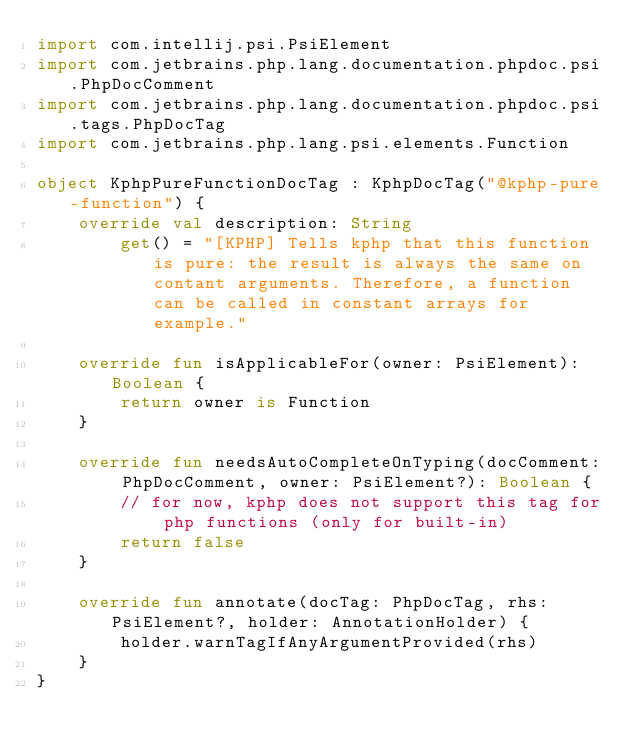<code> <loc_0><loc_0><loc_500><loc_500><_Kotlin_>import com.intellij.psi.PsiElement
import com.jetbrains.php.lang.documentation.phpdoc.psi.PhpDocComment
import com.jetbrains.php.lang.documentation.phpdoc.psi.tags.PhpDocTag
import com.jetbrains.php.lang.psi.elements.Function

object KphpPureFunctionDocTag : KphpDocTag("@kphp-pure-function") {
    override val description: String
        get() = "[KPHP] Tells kphp that this function is pure: the result is always the same on contant arguments. Therefore, a function can be called in constant arrays for example."

    override fun isApplicableFor(owner: PsiElement): Boolean {
        return owner is Function
    }

    override fun needsAutoCompleteOnTyping(docComment: PhpDocComment, owner: PsiElement?): Boolean {
        // for now, kphp does not support this tag for php functions (only for built-in)
        return false
    }

    override fun annotate(docTag: PhpDocTag, rhs: PsiElement?, holder: AnnotationHolder) {
        holder.warnTagIfAnyArgumentProvided(rhs)
    }
}
</code> 